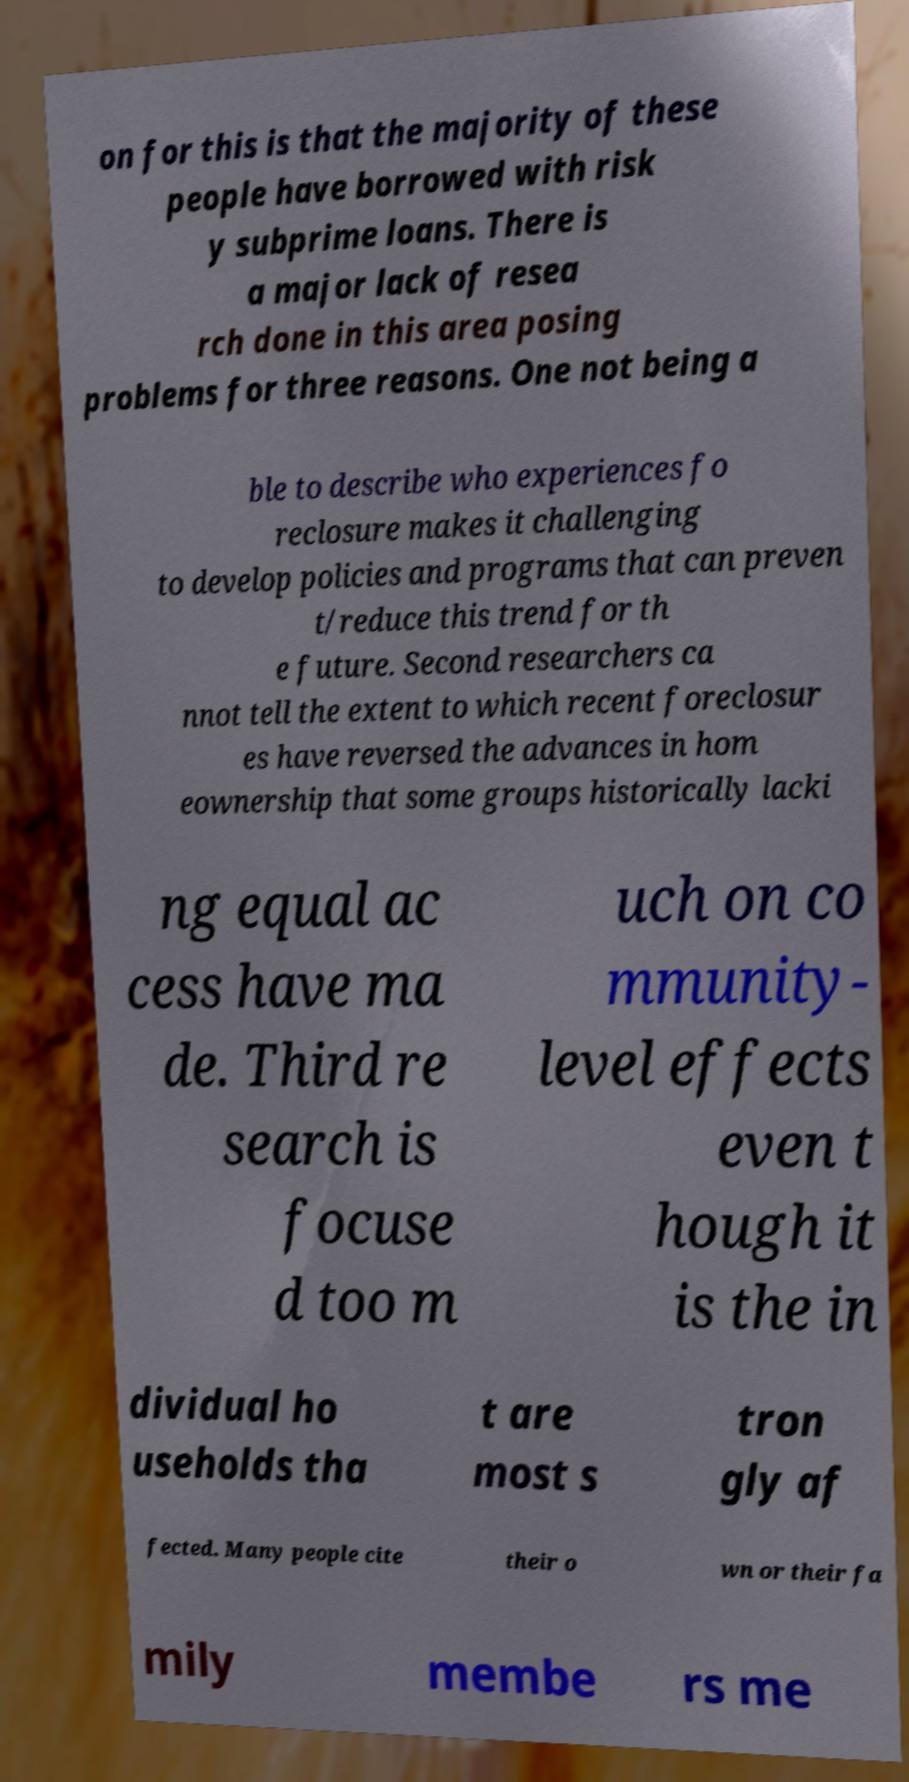Could you extract and type out the text from this image? on for this is that the majority of these people have borrowed with risk y subprime loans. There is a major lack of resea rch done in this area posing problems for three reasons. One not being a ble to describe who experiences fo reclosure makes it challenging to develop policies and programs that can preven t/reduce this trend for th e future. Second researchers ca nnot tell the extent to which recent foreclosur es have reversed the advances in hom eownership that some groups historically lacki ng equal ac cess have ma de. Third re search is focuse d too m uch on co mmunity- level effects even t hough it is the in dividual ho useholds tha t are most s tron gly af fected. Many people cite their o wn or their fa mily membe rs me 